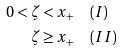Convert formula to latex. <formula><loc_0><loc_0><loc_500><loc_500>0 < \zeta < x _ { + } & \quad ( I ) \\ \zeta \geq x _ { + } & \quad ( I I )</formula> 